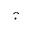Convert formula to latex. <formula><loc_0><loc_0><loc_500><loc_500>\widehat { \cdot }</formula> 